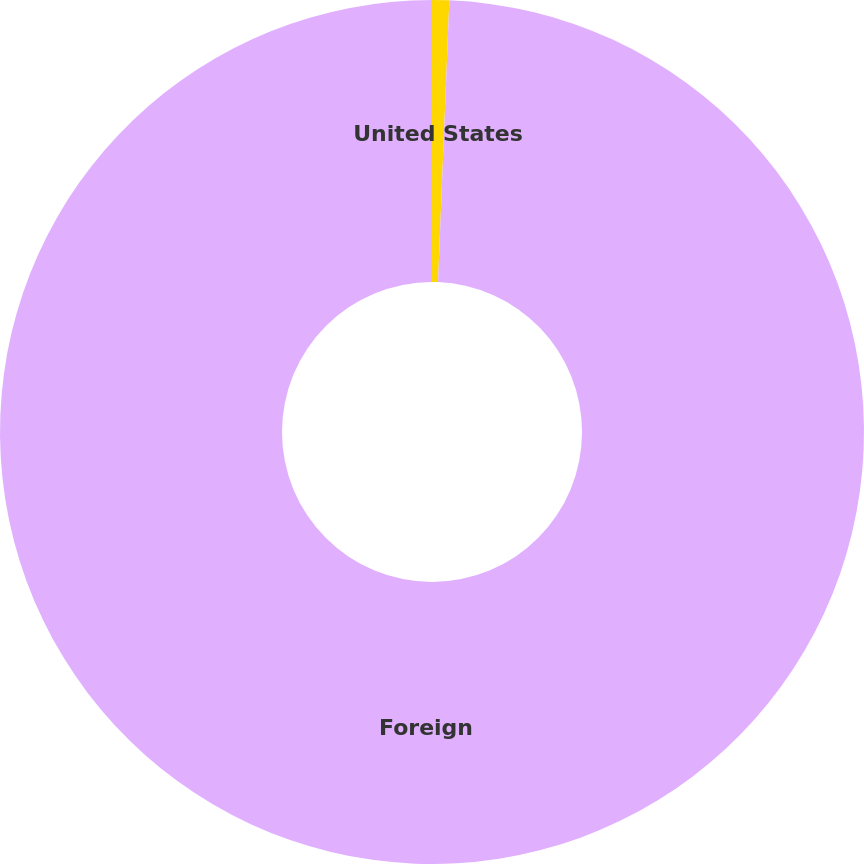Convert chart. <chart><loc_0><loc_0><loc_500><loc_500><pie_chart><fcel>United States<fcel>Foreign<nl><fcel>0.64%<fcel>99.36%<nl></chart> 